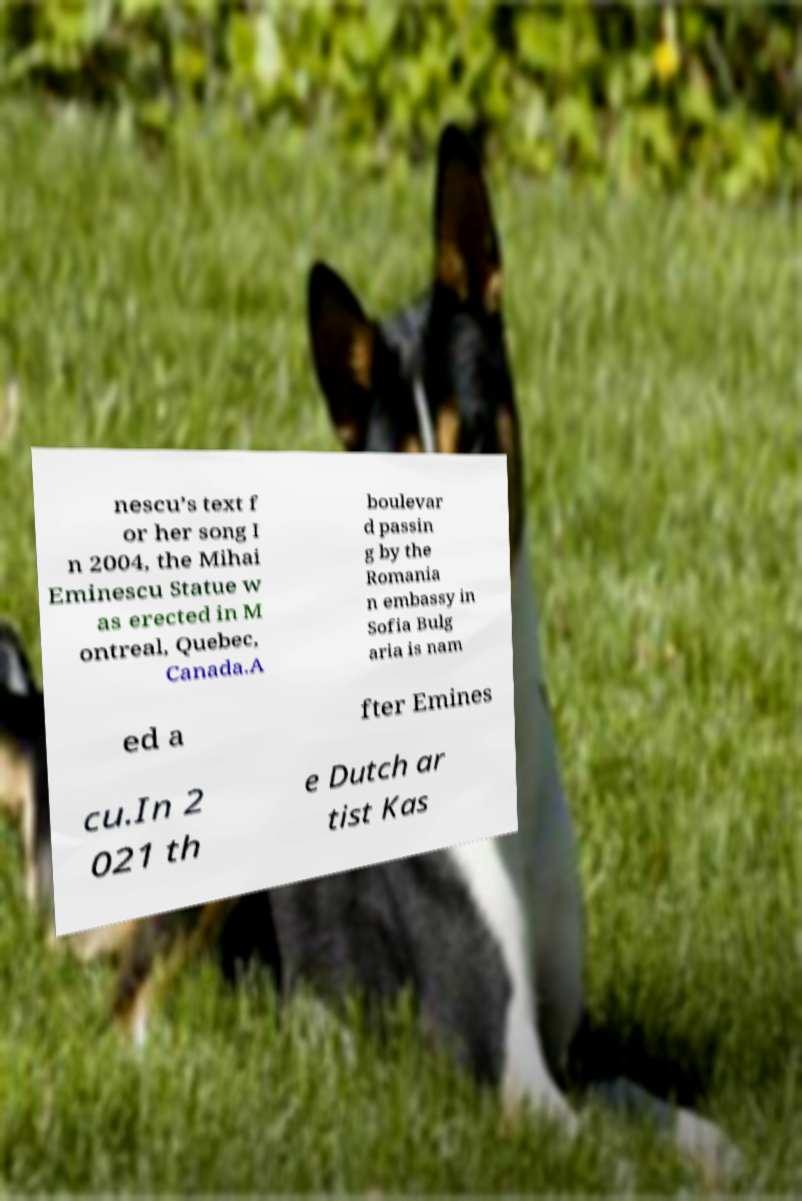I need the written content from this picture converted into text. Can you do that? nescu’s text f or her song I n 2004, the Mihai Eminescu Statue w as erected in M ontreal, Quebec, Canada.A boulevar d passin g by the Romania n embassy in Sofia Bulg aria is nam ed a fter Emines cu.In 2 021 th e Dutch ar tist Kas 